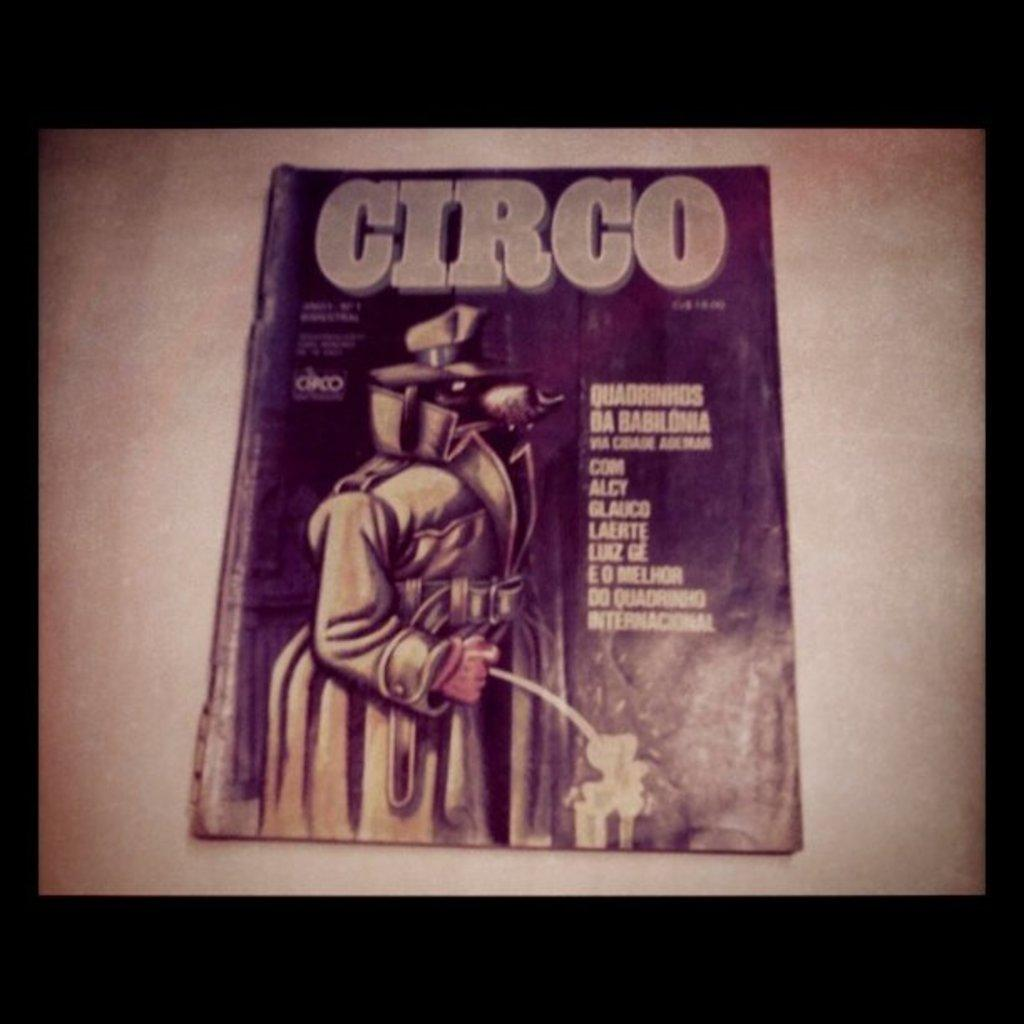<image>
Summarize the visual content of the image. Booklet that has a dog wearing a jacket and the word "CIRCO" on top. 